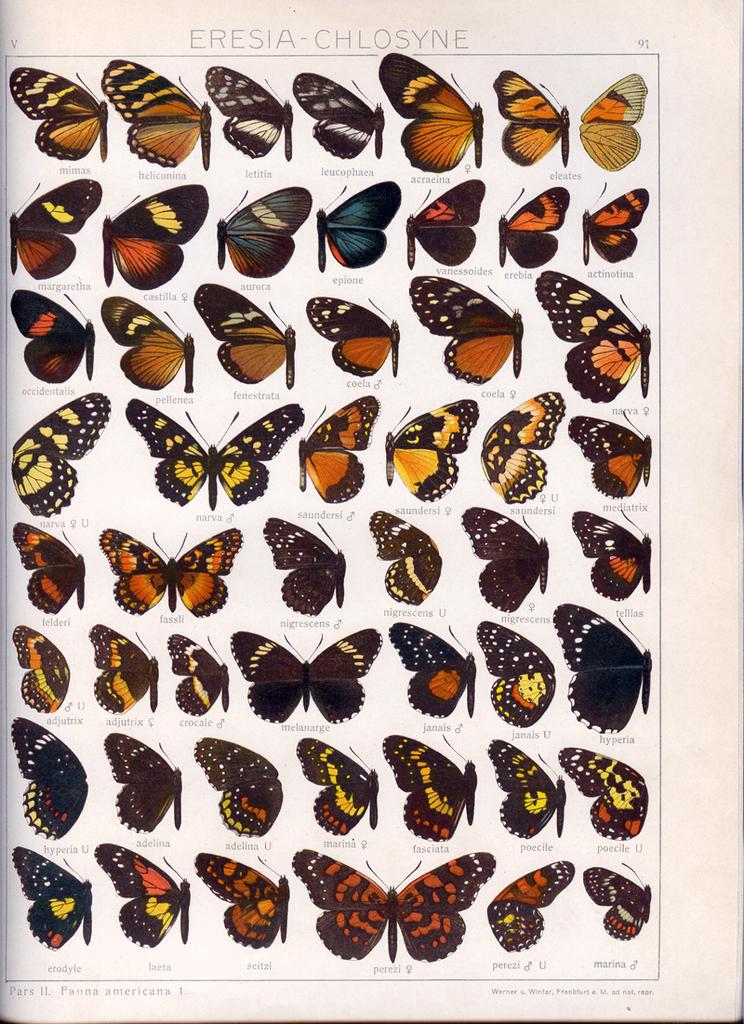What type of animals can be seen in the image? There are butterflies in the image. Can you describe the appearance of the butterflies? The butterflies are in different colors. What else is present in the image besides the butterflies? There is a paper with writing on it in the image. What type of star can be seen in the image? There is no star present in the image; it features butterflies and a paper with writing on it. Can you hear the butterflies laughing in the image? Butterflies do not have the ability to laugh, and there is no sound in the image. 